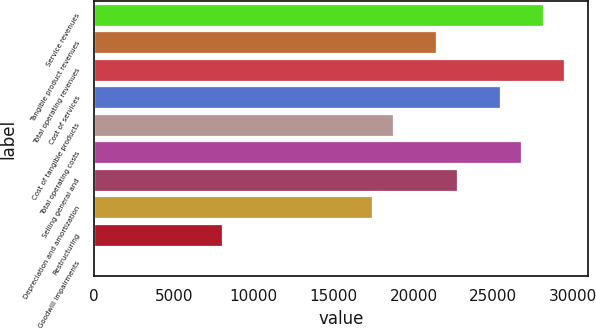Convert chart to OTSL. <chart><loc_0><loc_0><loc_500><loc_500><bar_chart><fcel>Service revenues<fcel>Tangible product revenues<fcel>Total operating revenues<fcel>Cost of services<fcel>Cost of tangible products<fcel>Total operating costs<fcel>Selling general and<fcel>Depreciation and amortization<fcel>Restructuring<fcel>Goodwill impairments<nl><fcel>28092.7<fcel>21404.2<fcel>29430.4<fcel>25417.3<fcel>18728.8<fcel>26755<fcel>22741.9<fcel>17391.1<fcel>8027.2<fcel>1<nl></chart> 